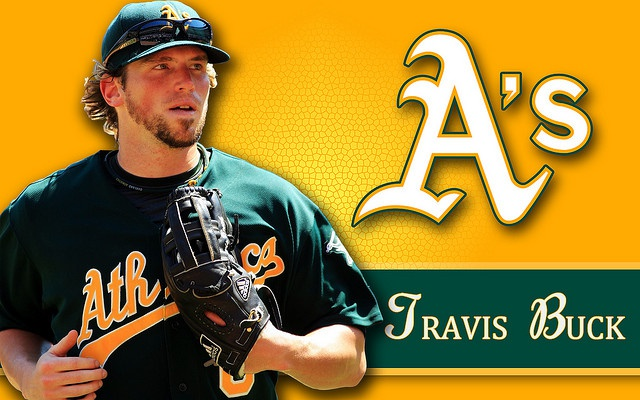Describe the objects in this image and their specific colors. I can see people in orange, black, brown, ivory, and salmon tones and baseball glove in orange, black, lightgray, gray, and darkgray tones in this image. 